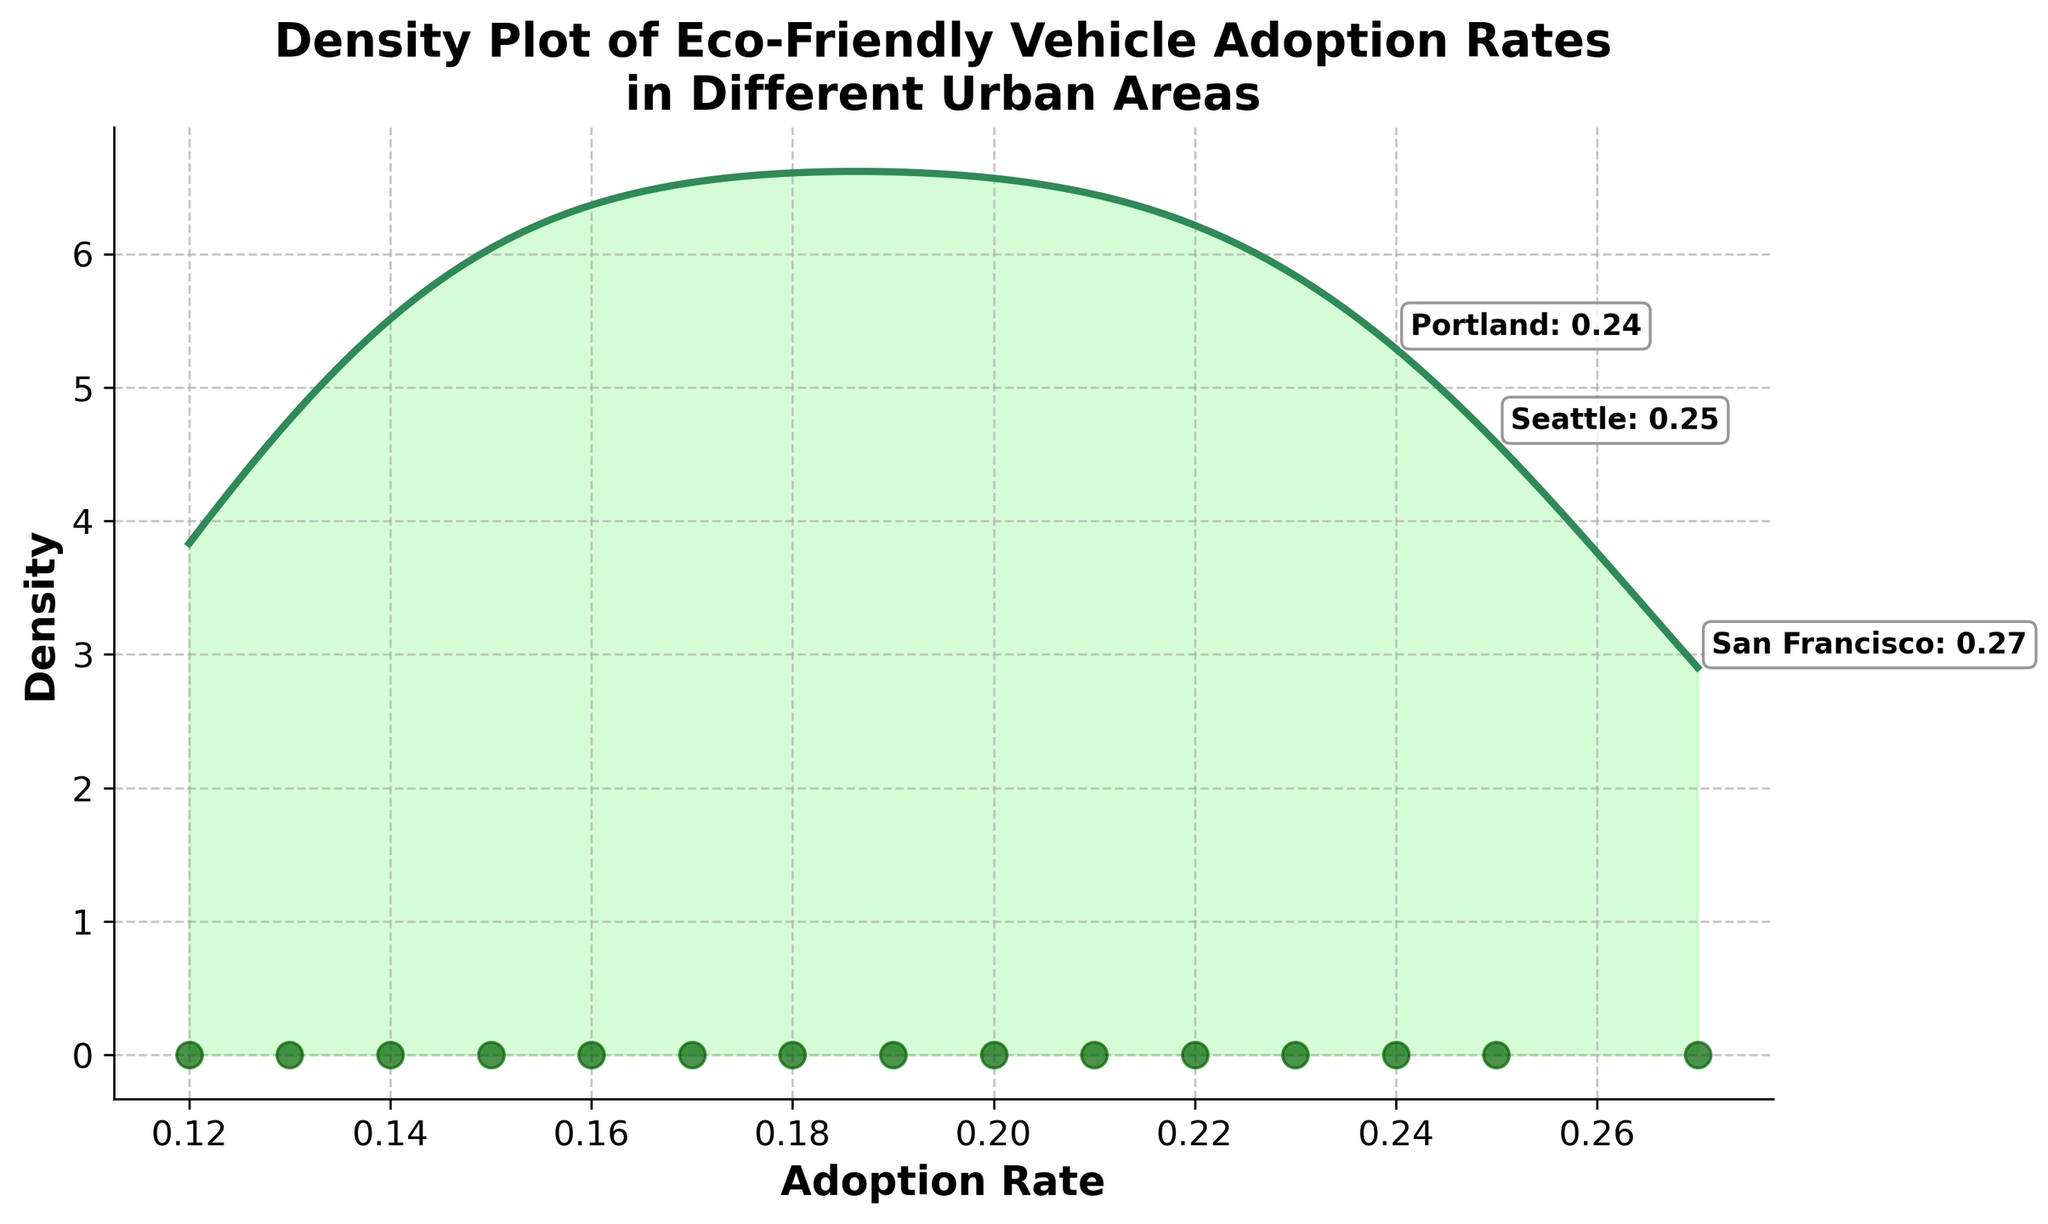What's the title of the figure? The title is prominently displayed at the top of the figure, and it states the primary focus of the plot.
Answer: Density Plot of Eco-Friendly Vehicle Adoption Rates in Different Urban Areas What does the x-axis represent? The x-axis label provides the detail that it represents the rate at which eco-friendly vehicles are being adopted.
Answer: Adoption Rate Which urban area has the highest adoption rate of eco-friendly vehicles, and what is the rate? The figure includes annotations for the top cities. Among them, San Francisco's annotation shows it has the highest adoption rate of 0.27.
Answer: San Francisco, 0.27 How many urban areas are represented in the density plot? By counting the number of scatter plot points along the x-axis, we can deduce the total number of urban areas represented.
Answer: 15 Is the density higher around lower or higher adoption rates? Observing the density curve, the density is more elevated around higher adoption rates, indicating a concentration of urban areas with higher adoption rates.
Answer: Higher adoption rates What are the adoption rates for Seattle and Portland, and which is higher? The scatter annotations show Seattle and Portland's adoption rates, allowing for comparison. Seattle has an adoption rate of 0.25, and Portland has 0.24.
Answer: Seattle, 0.25 What's the average adoption rate of the urban areas annotated as top 3 in the plot? The top 3 cities, according to the annotations, are San Francisco (0.27), Seattle (0.25), and Portland (0.24). The average is calculated as (0.27 + 0.25 + 0.24)/3.
Answer: 0.253 Which urban area has the lowest adoption rate, and what is the rate? By looking for the smallest scatter plot point along the x-axis and confirming with urban area details, we identify Phoenix as having the lowest rate of 0.12.
Answer: Phoenix, 0.12 What color fills the space under the density curve? The fill color for the area under the curve is light green, providing a visual distinct from the density line.
Answer: Light Green (Approx. '#98FB98') Do the adoption rates show more variation among higher or lower rate urban areas? The density plot indicates the spread and concentration of data points, showcasing more variation among lower adoption rates as the density is more spread out in that range.
Answer: Lower adoption rates 